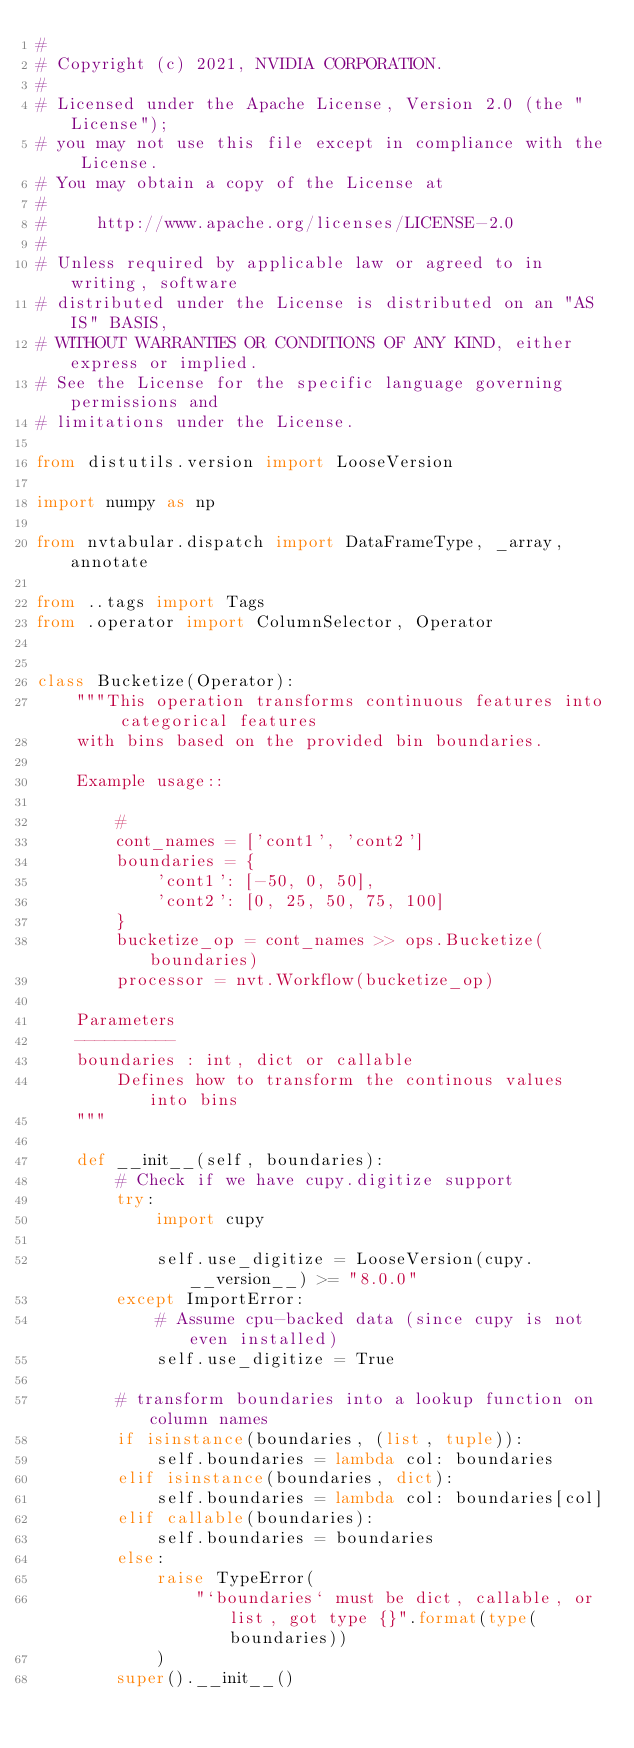Convert code to text. <code><loc_0><loc_0><loc_500><loc_500><_Python_>#
# Copyright (c) 2021, NVIDIA CORPORATION.
#
# Licensed under the Apache License, Version 2.0 (the "License");
# you may not use this file except in compliance with the License.
# You may obtain a copy of the License at
#
#     http://www.apache.org/licenses/LICENSE-2.0
#
# Unless required by applicable law or agreed to in writing, software
# distributed under the License is distributed on an "AS IS" BASIS,
# WITHOUT WARRANTIES OR CONDITIONS OF ANY KIND, either express or implied.
# See the License for the specific language governing permissions and
# limitations under the License.

from distutils.version import LooseVersion

import numpy as np

from nvtabular.dispatch import DataFrameType, _array, annotate

from ..tags import Tags
from .operator import ColumnSelector, Operator


class Bucketize(Operator):
    """This operation transforms continuous features into categorical features
    with bins based on the provided bin boundaries.

    Example usage::

        #
        cont_names = ['cont1', 'cont2']
        boundaries = {
            'cont1': [-50, 0, 50],
            'cont2': [0, 25, 50, 75, 100]
        }
        bucketize_op = cont_names >> ops.Bucketize(boundaries)
        processor = nvt.Workflow(bucketize_op)

    Parameters
    ----------
    boundaries : int, dict or callable
        Defines how to transform the continous values into bins
    """

    def __init__(self, boundaries):
        # Check if we have cupy.digitize support
        try:
            import cupy

            self.use_digitize = LooseVersion(cupy.__version__) >= "8.0.0"
        except ImportError:
            # Assume cpu-backed data (since cupy is not even installed)
            self.use_digitize = True

        # transform boundaries into a lookup function on column names
        if isinstance(boundaries, (list, tuple)):
            self.boundaries = lambda col: boundaries
        elif isinstance(boundaries, dict):
            self.boundaries = lambda col: boundaries[col]
        elif callable(boundaries):
            self.boundaries = boundaries
        else:
            raise TypeError(
                "`boundaries` must be dict, callable, or list, got type {}".format(type(boundaries))
            )
        super().__init__()
</code> 